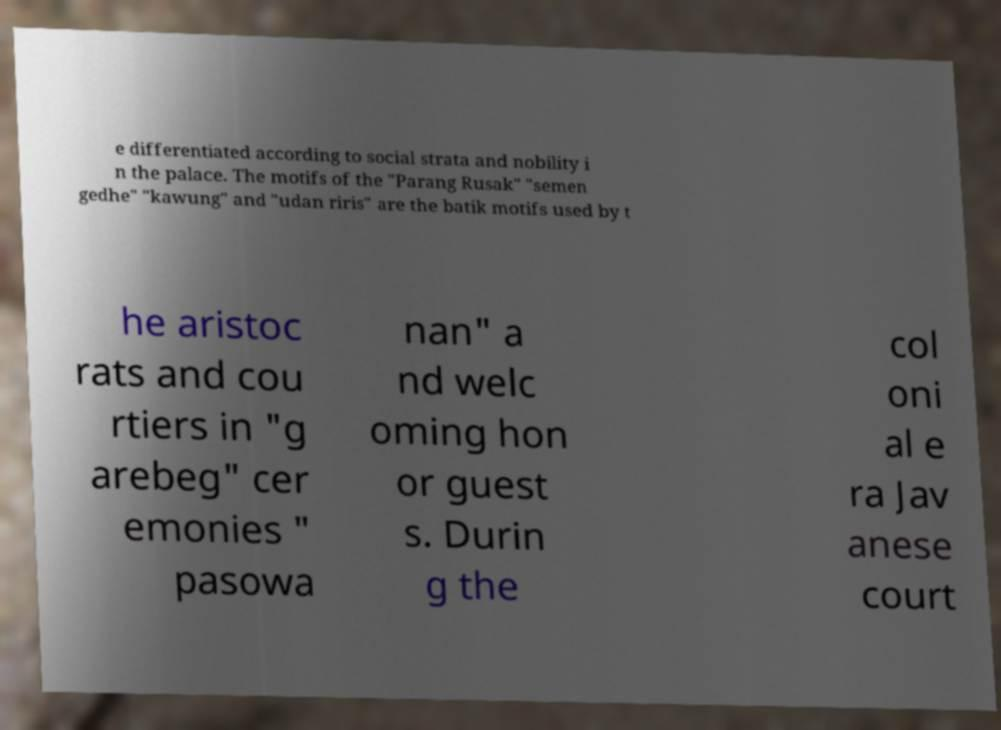Could you extract and type out the text from this image? e differentiated according to social strata and nobility i n the palace. The motifs of the "Parang Rusak" "semen gedhe" "kawung" and "udan riris" are the batik motifs used by t he aristoc rats and cou rtiers in "g arebeg" cer emonies " pasowa nan" a nd welc oming hon or guest s. Durin g the col oni al e ra Jav anese court 